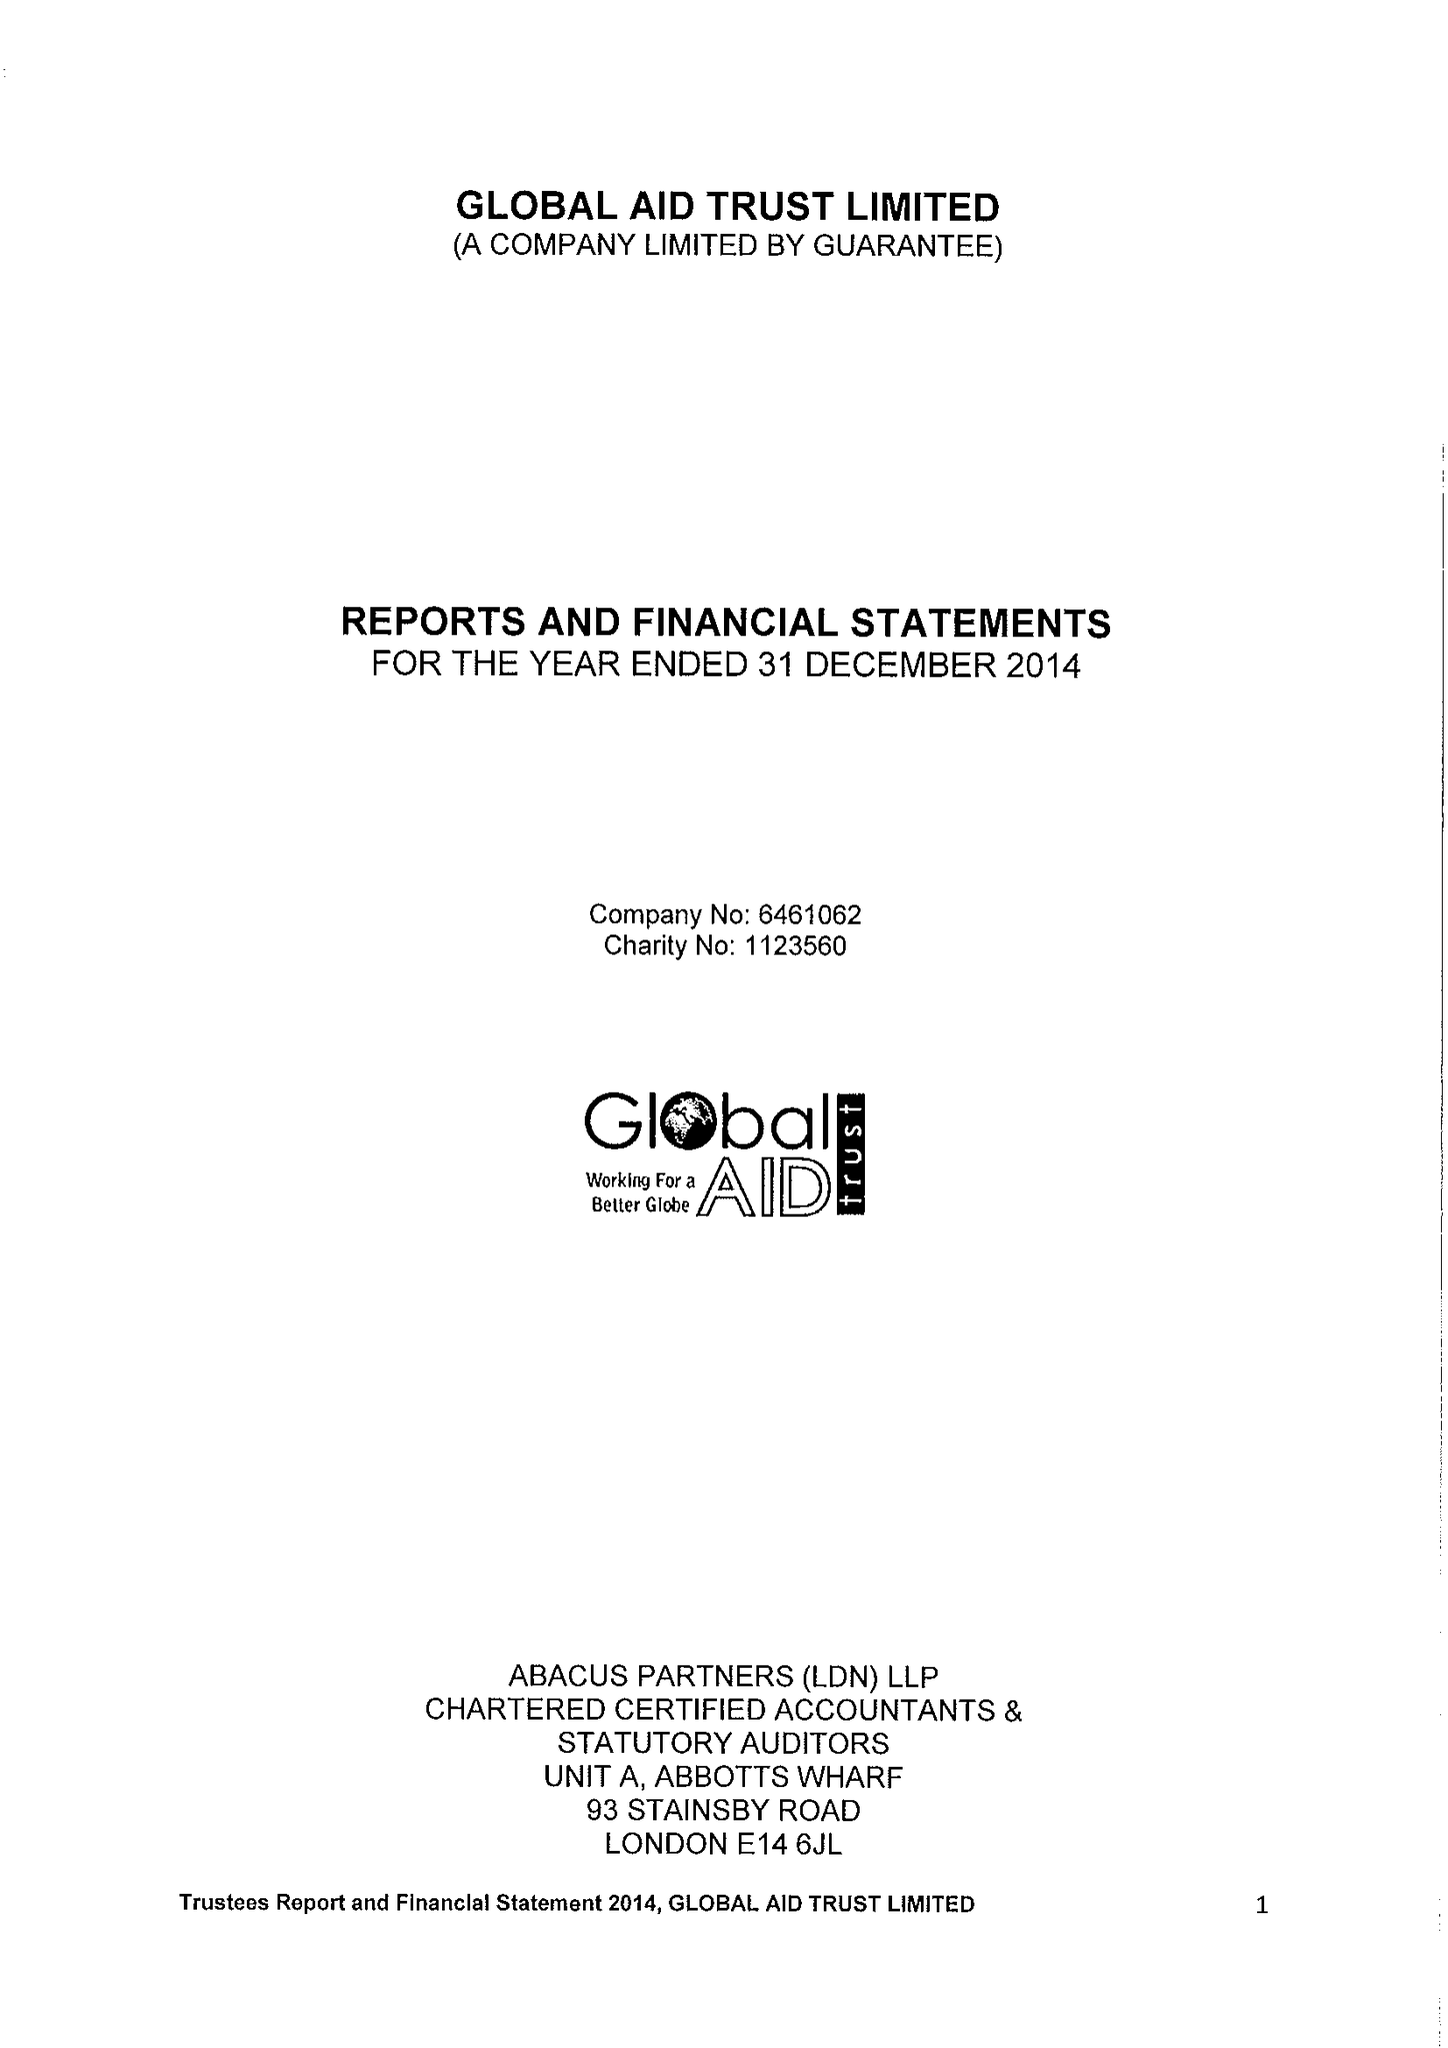What is the value for the address__street_line?
Answer the question using a single word or phrase. 80A ASHFIELD STREET 